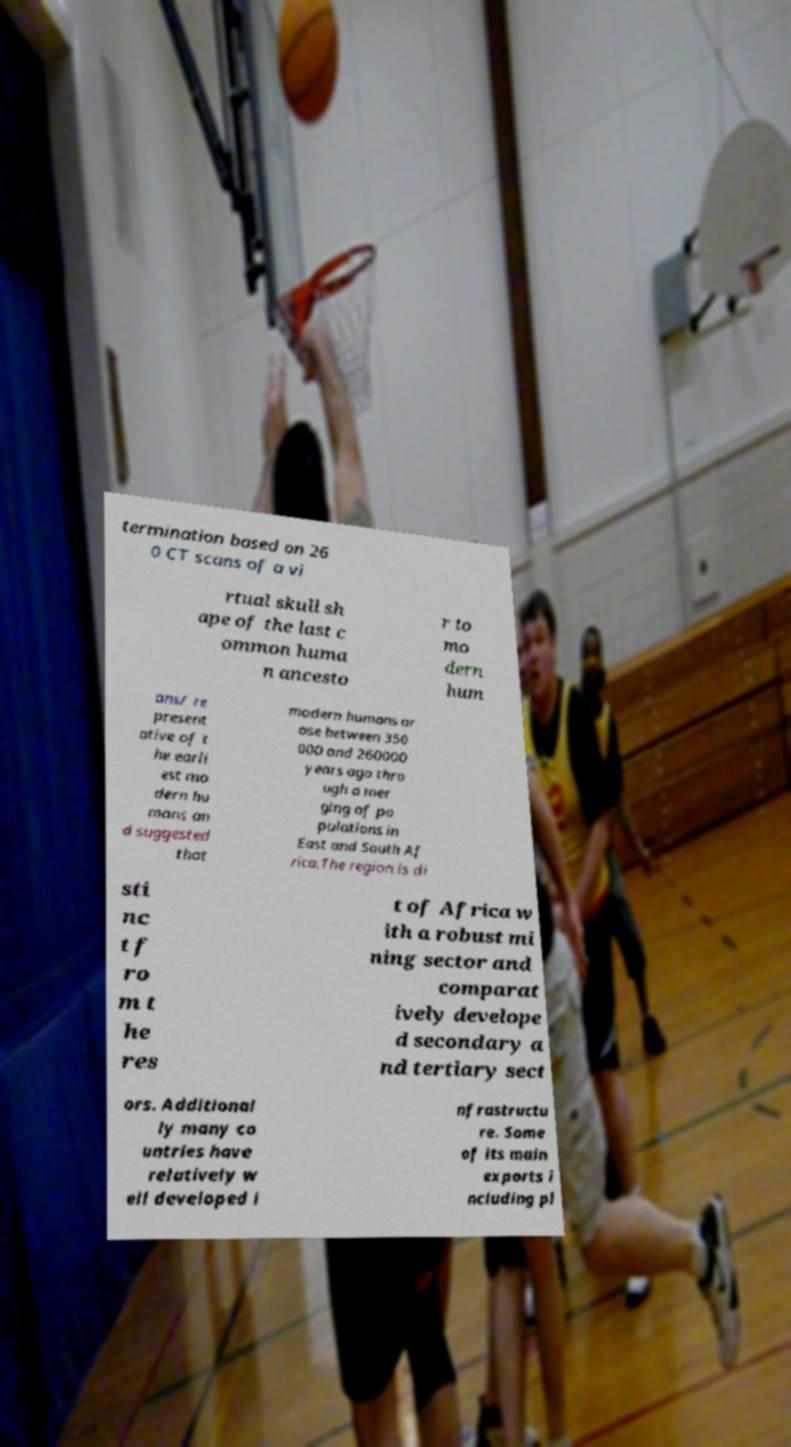Could you assist in decoding the text presented in this image and type it out clearly? termination based on 26 0 CT scans of a vi rtual skull sh ape of the last c ommon huma n ancesto r to mo dern hum ans/ re present ative of t he earli est mo dern hu mans an d suggested that modern humans ar ose between 350 000 and 260000 years ago thro ugh a mer ging of po pulations in East and South Af rica.The region is di sti nc t f ro m t he res t of Africa w ith a robust mi ning sector and comparat ively develope d secondary a nd tertiary sect ors. Additional ly many co untries have relatively w ell developed i nfrastructu re. Some of its main exports i ncluding pl 